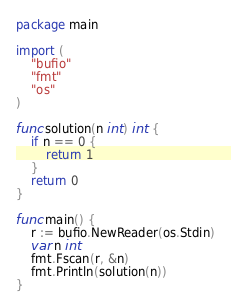Convert code to text. <code><loc_0><loc_0><loc_500><loc_500><_Go_>package main

import (
	"bufio"
	"fmt"
	"os"
)

func solution(n int) int {
	if n == 0 {
		return 1
	}
	return 0
}

func main() {
	r := bufio.NewReader(os.Stdin)
	var n int
	fmt.Fscan(r, &n)
	fmt.Println(solution(n))
}
</code> 